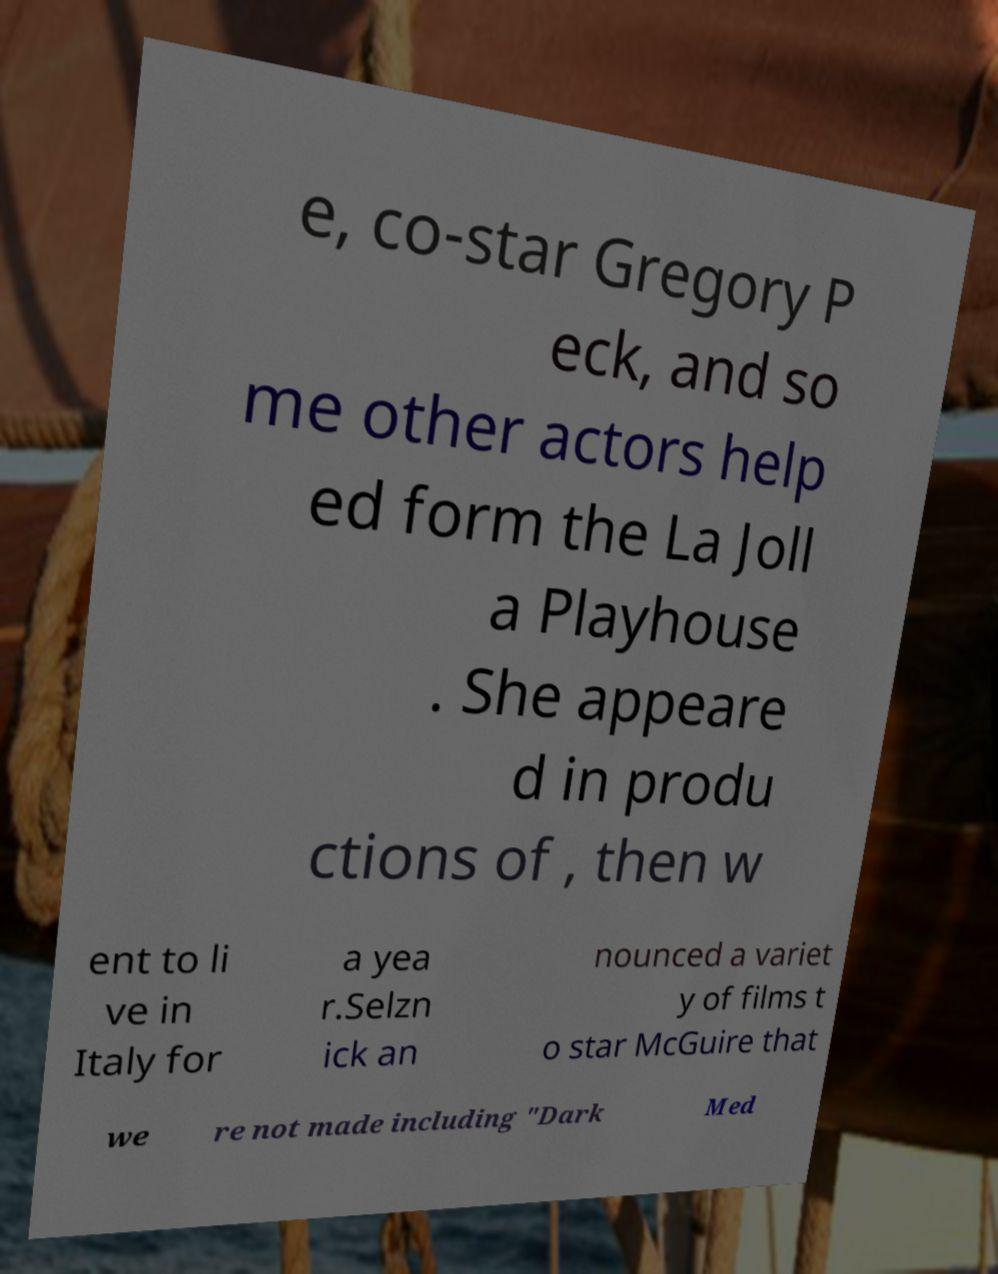Can you accurately transcribe the text from the provided image for me? e, co-star Gregory P eck, and so me other actors help ed form the La Joll a Playhouse . She appeare d in produ ctions of , then w ent to li ve in Italy for a yea r.Selzn ick an nounced a variet y of films t o star McGuire that we re not made including "Dark Med 